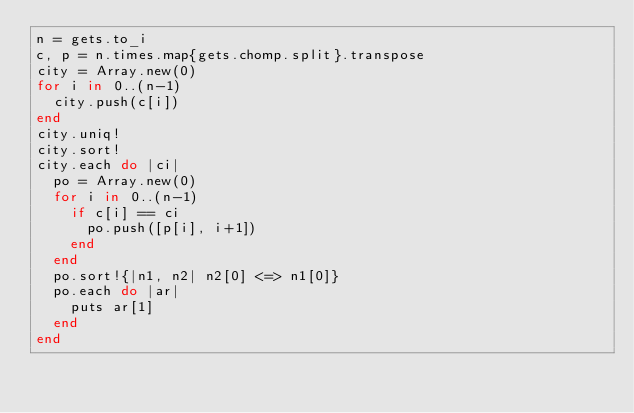Convert code to text. <code><loc_0><loc_0><loc_500><loc_500><_Ruby_>n = gets.to_i
c, p = n.times.map{gets.chomp.split}.transpose
city = Array.new(0)
for i in 0..(n-1)
  city.push(c[i])
end
city.uniq!
city.sort!
city.each do |ci|
  po = Array.new(0)
  for i in 0..(n-1)
    if c[i] == ci
      po.push([p[i], i+1])
    end
  end
  po.sort!{|n1, n2| n2[0] <=> n1[0]}
  po.each do |ar|
    puts ar[1]
  end
end
      
</code> 